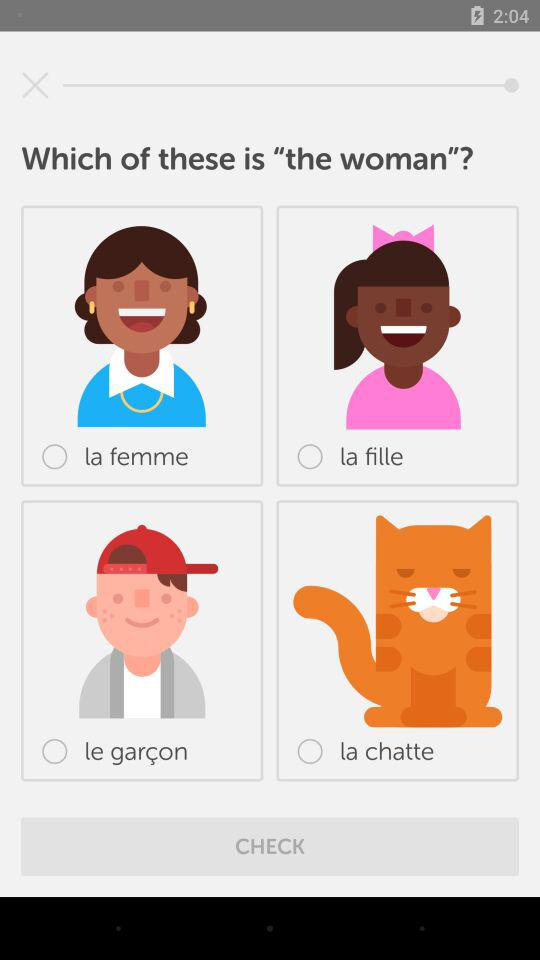What is the name of the boy?
When the provided information is insufficient, respond with <no answer>. <no answer> 